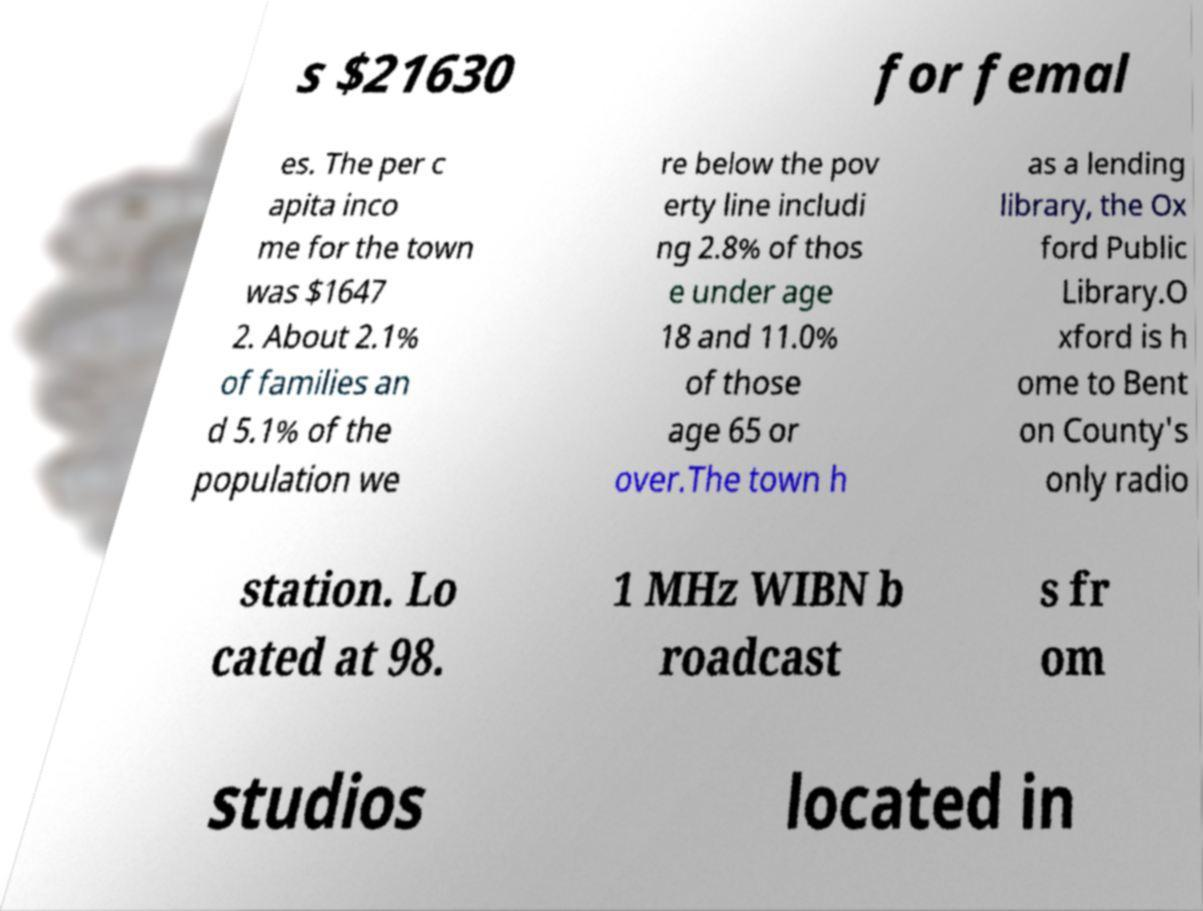I need the written content from this picture converted into text. Can you do that? s $21630 for femal es. The per c apita inco me for the town was $1647 2. About 2.1% of families an d 5.1% of the population we re below the pov erty line includi ng 2.8% of thos e under age 18 and 11.0% of those age 65 or over.The town h as a lending library, the Ox ford Public Library.O xford is h ome to Bent on County's only radio station. Lo cated at 98. 1 MHz WIBN b roadcast s fr om studios located in 